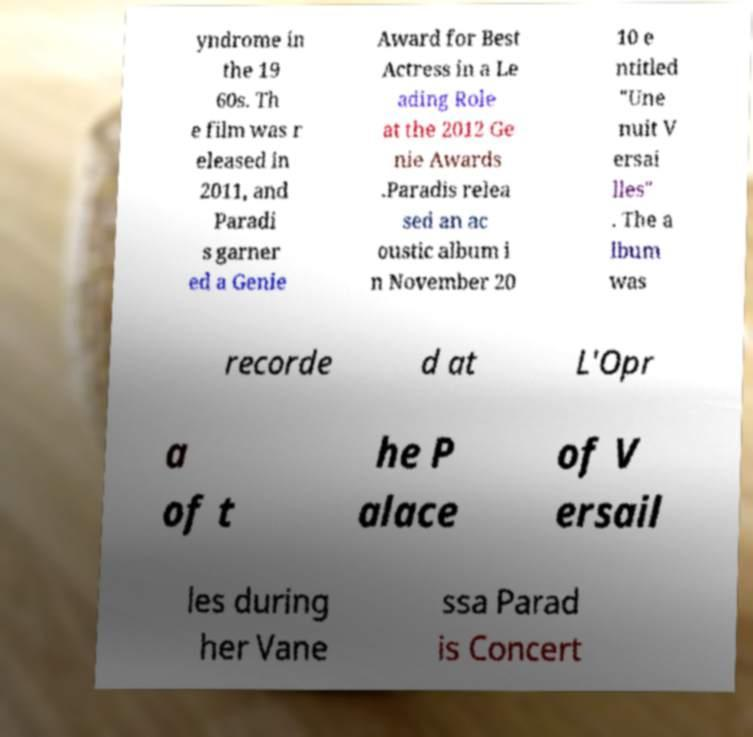Could you assist in decoding the text presented in this image and type it out clearly? yndrome in the 19 60s. Th e film was r eleased in 2011, and Paradi s garner ed a Genie Award for Best Actress in a Le ading Role at the 2012 Ge nie Awards .Paradis relea sed an ac oustic album i n November 20 10 e ntitled "Une nuit V ersai lles" . The a lbum was recorde d at L'Opr a of t he P alace of V ersail les during her Vane ssa Parad is Concert 